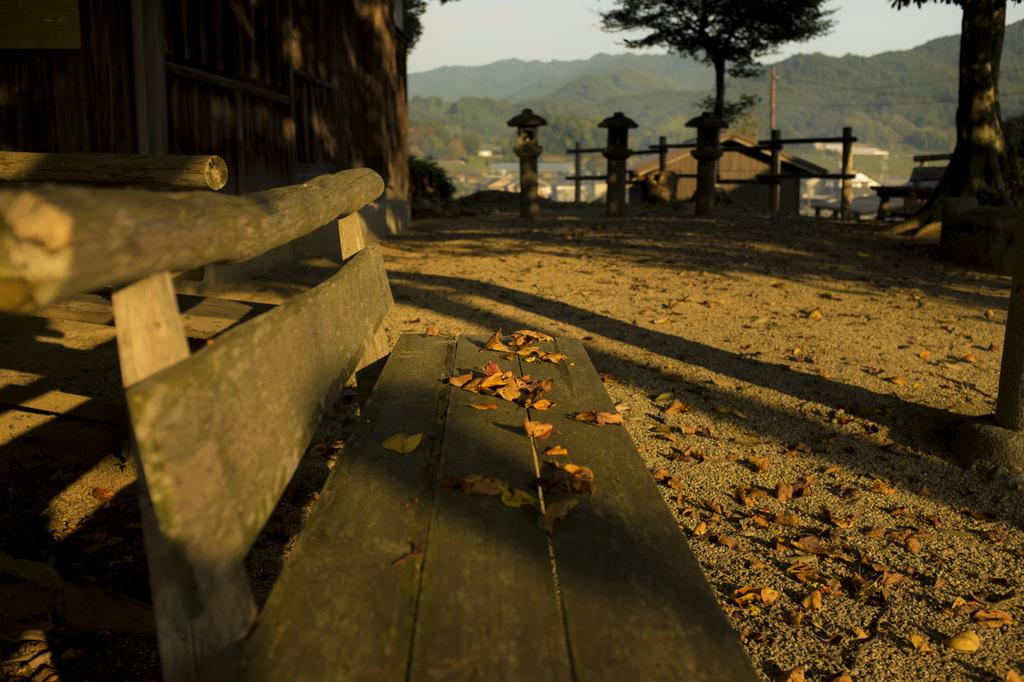What type of seating is visible in the image? There is a bench in the image. What is on top of the bench? Leaves are on the bench. What can be seen beneath the bench? There is a ground visible in the image. What is visible in the background of the image? There is fencing, trees, and mountains in the background of the image. What type of wall is present in the top left of the image? There is a wooden wall on the top left of the image. What type of parcel is being taught in the image? There is no parcel or teaching activity present in the image. What type of field can be seen in the image? There is no field visible in the image. 